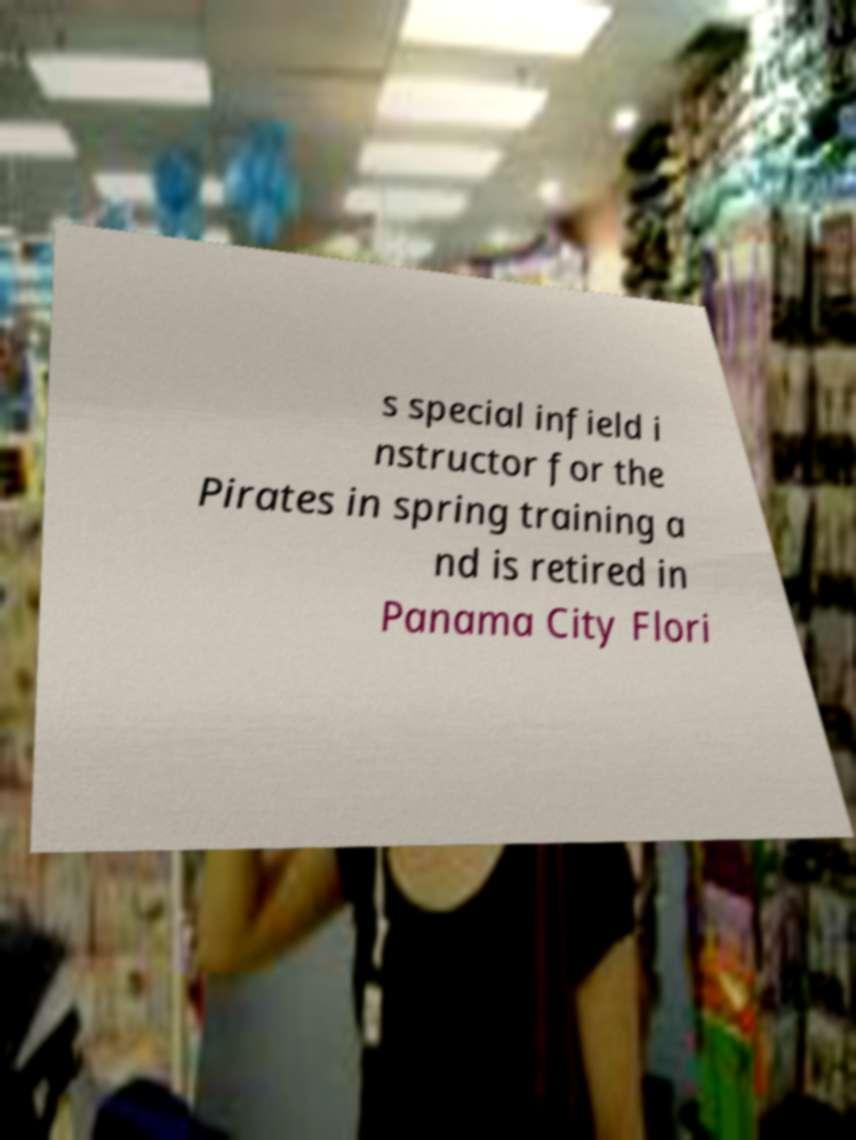There's text embedded in this image that I need extracted. Can you transcribe it verbatim? s special infield i nstructor for the Pirates in spring training a nd is retired in Panama City Flori 